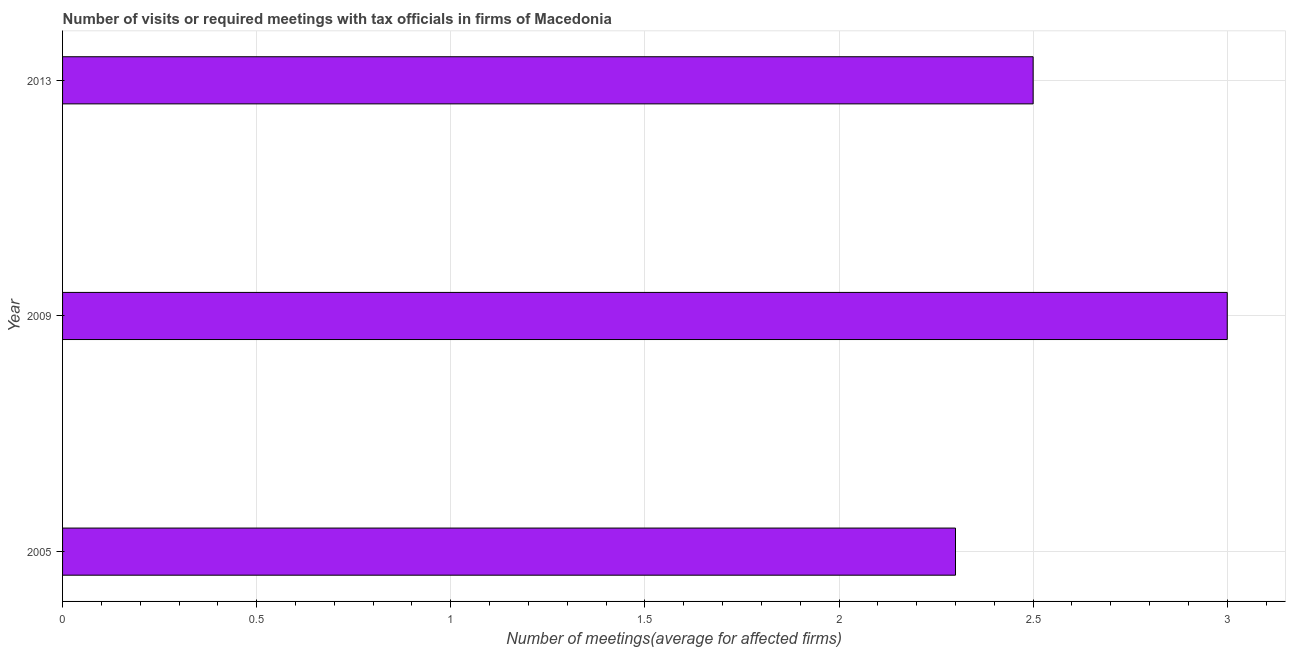Does the graph contain grids?
Give a very brief answer. Yes. What is the title of the graph?
Provide a short and direct response. Number of visits or required meetings with tax officials in firms of Macedonia. What is the label or title of the X-axis?
Ensure brevity in your answer.  Number of meetings(average for affected firms). What is the number of required meetings with tax officials in 2013?
Provide a succinct answer. 2.5. Across all years, what is the maximum number of required meetings with tax officials?
Offer a terse response. 3. In which year was the number of required meetings with tax officials minimum?
Keep it short and to the point. 2005. What is the average number of required meetings with tax officials per year?
Your answer should be very brief. 2.6. Do a majority of the years between 2009 and 2005 (inclusive) have number of required meetings with tax officials greater than 2.2 ?
Make the answer very short. No. What is the ratio of the number of required meetings with tax officials in 2009 to that in 2013?
Offer a terse response. 1.2. Is the number of required meetings with tax officials in 2005 less than that in 2013?
Ensure brevity in your answer.  Yes. What is the difference between the highest and the second highest number of required meetings with tax officials?
Your answer should be very brief. 0.5. Is the sum of the number of required meetings with tax officials in 2005 and 2009 greater than the maximum number of required meetings with tax officials across all years?
Give a very brief answer. Yes. In how many years, is the number of required meetings with tax officials greater than the average number of required meetings with tax officials taken over all years?
Your answer should be compact. 1. How many bars are there?
Your answer should be compact. 3. Are all the bars in the graph horizontal?
Offer a very short reply. Yes. Are the values on the major ticks of X-axis written in scientific E-notation?
Your response must be concise. No. What is the Number of meetings(average for affected firms) of 2009?
Offer a terse response. 3. What is the Number of meetings(average for affected firms) in 2013?
Your response must be concise. 2.5. What is the difference between the Number of meetings(average for affected firms) in 2005 and 2009?
Your response must be concise. -0.7. What is the difference between the Number of meetings(average for affected firms) in 2005 and 2013?
Your answer should be compact. -0.2. What is the difference between the Number of meetings(average for affected firms) in 2009 and 2013?
Ensure brevity in your answer.  0.5. What is the ratio of the Number of meetings(average for affected firms) in 2005 to that in 2009?
Ensure brevity in your answer.  0.77. What is the ratio of the Number of meetings(average for affected firms) in 2005 to that in 2013?
Offer a terse response. 0.92. What is the ratio of the Number of meetings(average for affected firms) in 2009 to that in 2013?
Ensure brevity in your answer.  1.2. 